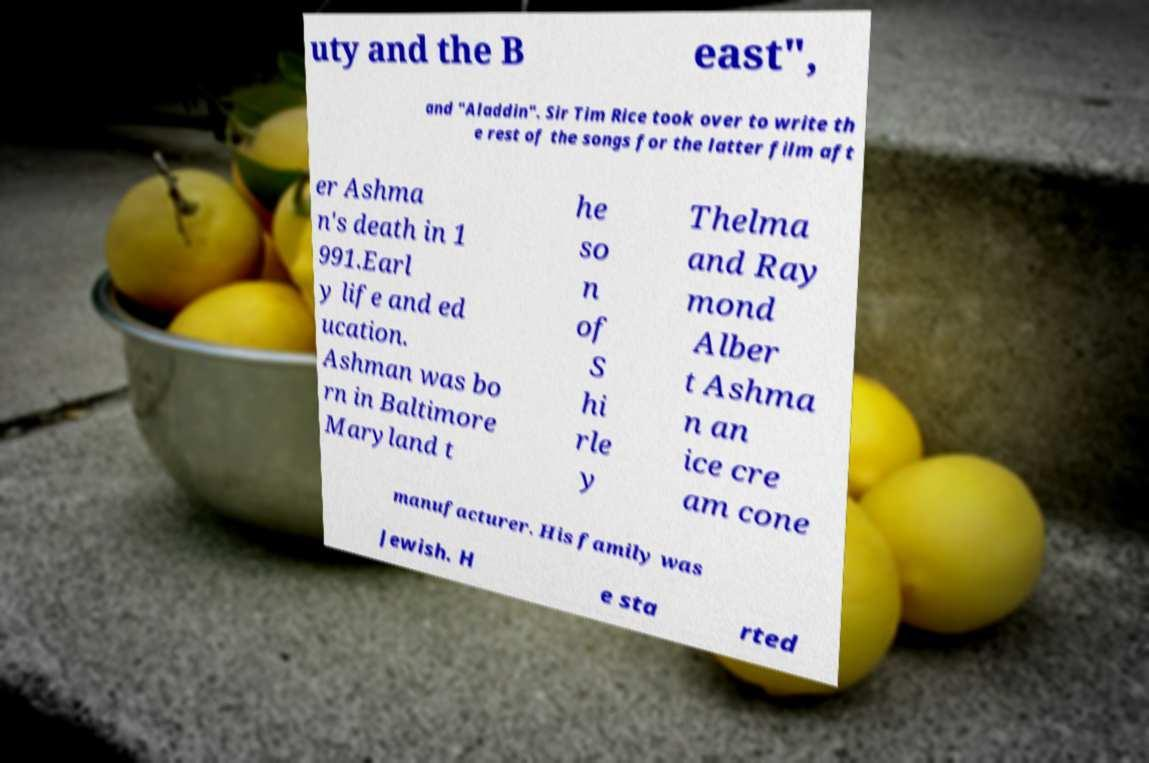Could you extract and type out the text from this image? uty and the B east", and "Aladdin". Sir Tim Rice took over to write th e rest of the songs for the latter film aft er Ashma n's death in 1 991.Earl y life and ed ucation. Ashman was bo rn in Baltimore Maryland t he so n of S hi rle y Thelma and Ray mond Alber t Ashma n an ice cre am cone manufacturer. His family was Jewish. H e sta rted 